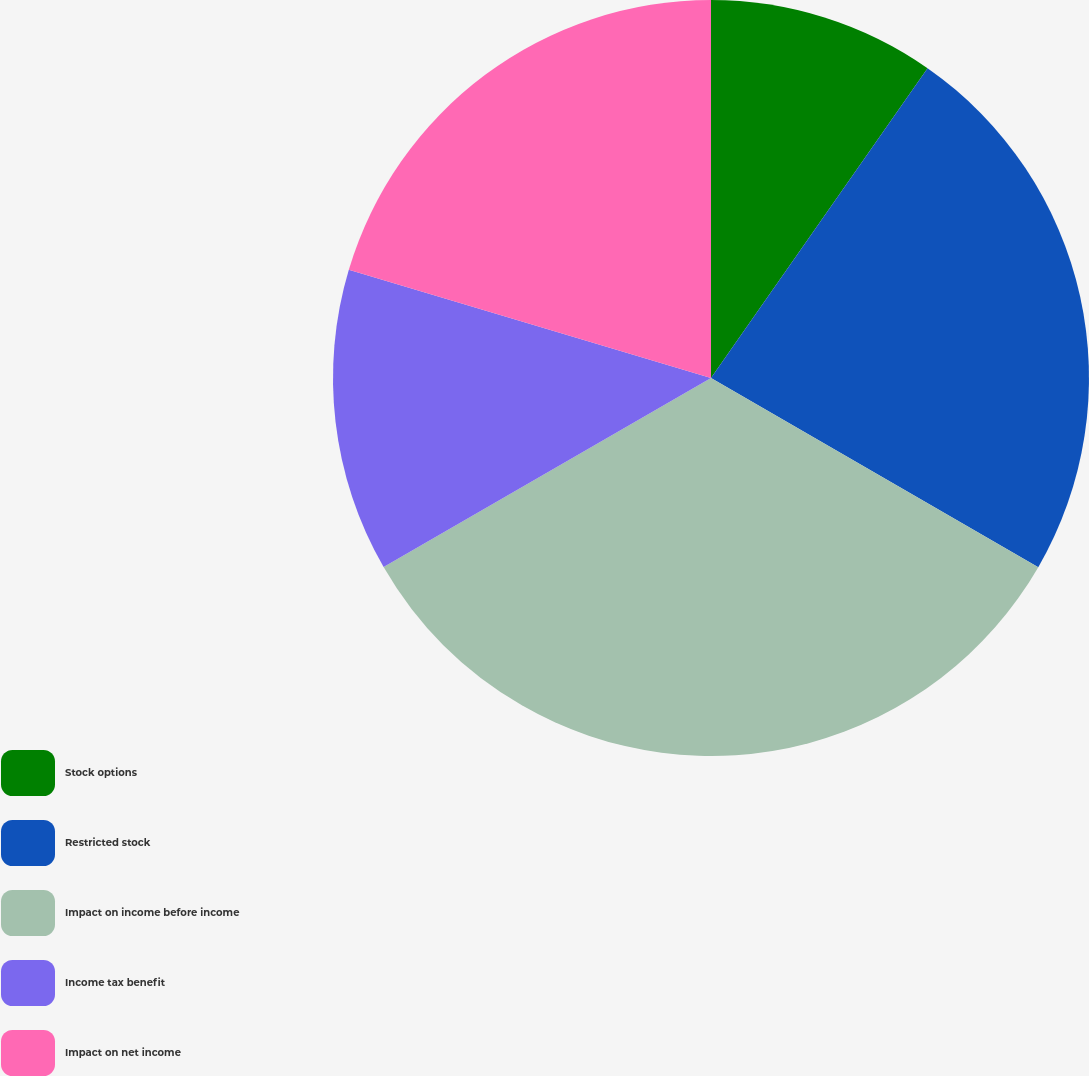Convert chart to OTSL. <chart><loc_0><loc_0><loc_500><loc_500><pie_chart><fcel>Stock options<fcel>Restricted stock<fcel>Impact on income before income<fcel>Income tax benefit<fcel>Impact on net income<nl><fcel>9.71%<fcel>23.63%<fcel>33.33%<fcel>12.95%<fcel>20.38%<nl></chart> 